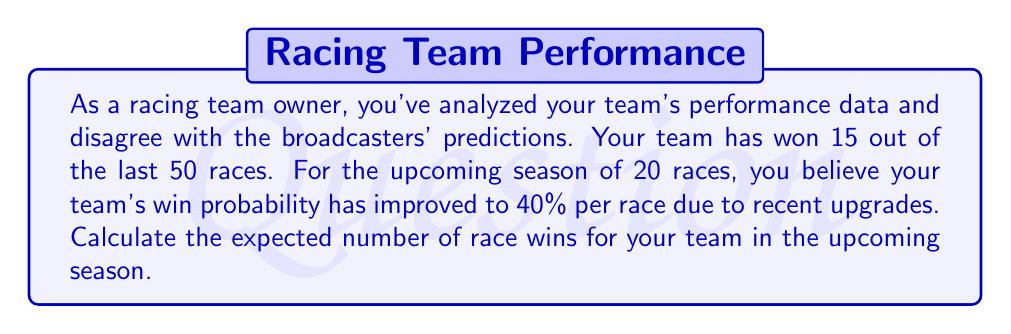Can you answer this question? Let's approach this step-by-step:

1) First, we need to understand what expected value means. The expected value is the average outcome of an experiment if it is repeated many times.

2) In this case, each race can be considered a separate experiment with two possible outcomes: win (1) or lose (0).

3) The probability of winning each race is given as 40% or 0.4.

4) For a single race, the expected value would be:
   $E(\text{single race}) = 1 \cdot 0.4 + 0 \cdot 0.6 = 0.4$

5) Since there are 20 races in the season, and each race is independent, we can use the linearity of expectation. This means we can multiply the expected value of a single race by the number of races:

   $E(\text{season}) = 20 \cdot E(\text{single race}) = 20 \cdot 0.4 = 8$

6) Therefore, the expected number of race wins for the upcoming season is 8.

This calculation suggests that, based on your analysis, your team can expect to win 8 races on average in the upcoming season, which is significantly higher than what the current win rate (15 out of 50, or 30%) might suggest.
Answer: 8 race wins 